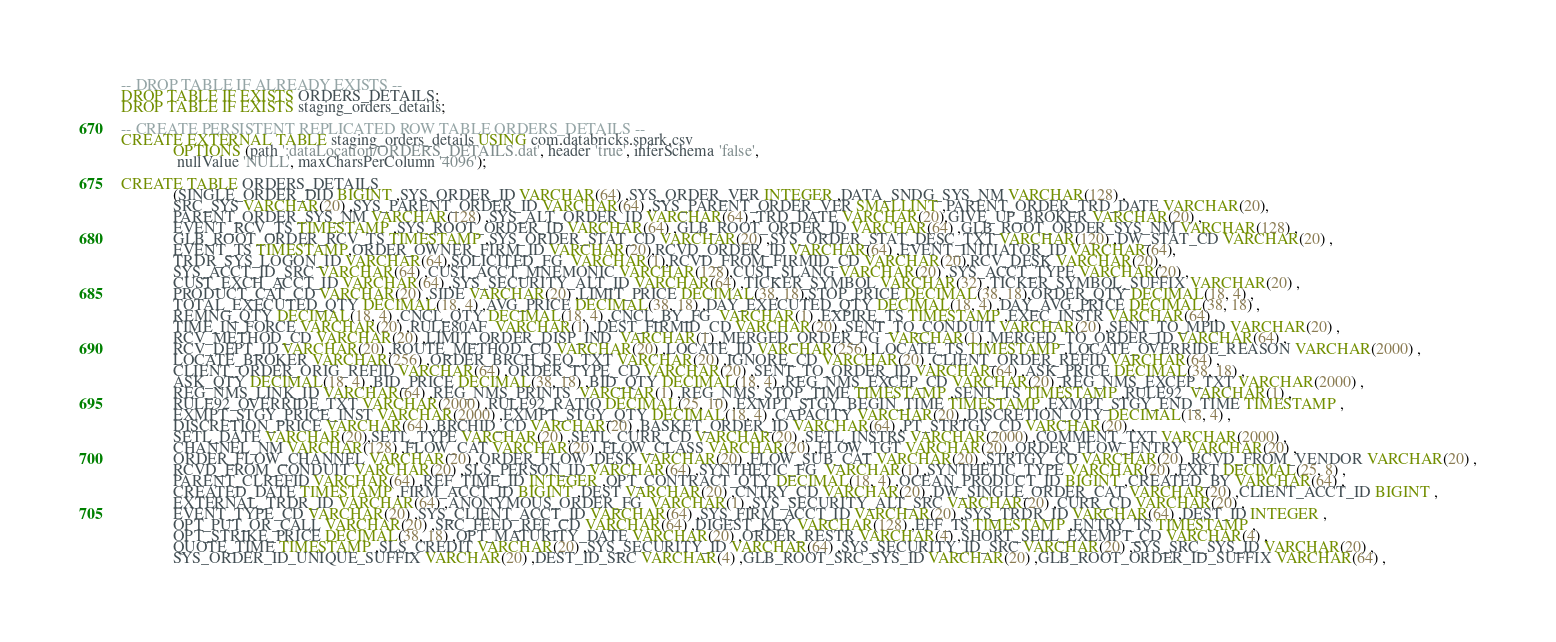Convert code to text. <code><loc_0><loc_0><loc_500><loc_500><_SQL_>-- DROP TABLE IF ALREADY EXISTS --
DROP TABLE IF EXISTS ORDERS_DETAILS;
DROP TABLE IF EXISTS staging_orders_details;

-- CREATE PERSISTENT REPLICATED ROW TABLE ORDERS_DETAILS --
CREATE EXTERNAL TABLE staging_orders_details USING com.databricks.spark.csv
             OPTIONS (path ':dataLocation/ORDERS_DETAILS.dat', header 'true', inferSchema 'false',
              nullValue 'NULL', maxCharsPerColumn '4096');

CREATE TABLE ORDERS_DETAILS
             (SINGLE_ORDER_DID BIGINT ,SYS_ORDER_ID VARCHAR(64) ,SYS_ORDER_VER INTEGER ,DATA_SNDG_SYS_NM VARCHAR(128) ,
             SRC_SYS VARCHAR(20) ,SYS_PARENT_ORDER_ID VARCHAR(64) ,SYS_PARENT_ORDER_VER SMALLINT ,PARENT_ORDER_TRD_DATE VARCHAR(20),
             PARENT_ORDER_SYS_NM VARCHAR(128) ,SYS_ALT_ORDER_ID VARCHAR(64) ,TRD_DATE VARCHAR(20),GIVE_UP_BROKER VARCHAR(20) ,
             EVENT_RCV_TS TIMESTAMP ,SYS_ROOT_ORDER_ID VARCHAR(64) ,GLB_ROOT_ORDER_ID VARCHAR(64) ,GLB_ROOT_ORDER_SYS_NM VARCHAR(128) ,
             GLB_ROOT_ORDER_RCV_TS TIMESTAMP ,SYS_ORDER_STAT_CD VARCHAR(20) ,SYS_ORDER_STAT_DESC_TXT VARCHAR(120) ,DW_STAT_CD VARCHAR(20) ,
             EVENT_TS TIMESTAMP,ORDER_OWNER_FIRM_ID VARCHAR(20),RCVD_ORDER_ID VARCHAR(64) ,EVENT_INITIATOR_ID VARCHAR(64),
             TRDR_SYS_LOGON_ID VARCHAR(64),SOLICITED_FG  VARCHAR(1),RCVD_FROM_FIRMID_CD VARCHAR(20),RCV_DESK VARCHAR(20),
             SYS_ACCT_ID_SRC VARCHAR(64) ,CUST_ACCT_MNEMONIC VARCHAR(128),CUST_SLANG VARCHAR(20) ,SYS_ACCT_TYPE VARCHAR(20) ,
             CUST_EXCH_ACCT_ID VARCHAR(64) ,SYS_SECURITY_ALT_ID VARCHAR(64) ,TICKER_SYMBOL VARCHAR(32) ,TICKER_SYMBOL_SUFFIX VARCHAR(20) ,
             PRODUCT_CAT_CD VARCHAR(20) ,SIDE VARCHAR(20) ,LIMIT_PRICE DECIMAL(38, 18),STOP_PRICE DECIMAL(38, 18),ORDER_QTY DECIMAL(18, 4) ,
             TOTAL_EXECUTED_QTY DECIMAL(18, 4) ,AVG_PRICE DECIMAL(38, 18) ,DAY_EXECUTED_QTY DECIMAL(18, 4) ,DAY_AVG_PRICE DECIMAL(38, 18) ,
             REMNG_QTY DECIMAL(18, 4) ,CNCL_QTY DECIMAL(18, 4) ,CNCL_BY_FG  VARCHAR(1) ,EXPIRE_TS TIMESTAMP ,EXEC_INSTR VARCHAR(64) ,
             TIME_IN_FORCE VARCHAR(20) ,RULE80AF  VARCHAR(1) ,DEST_FIRMID_CD VARCHAR(20) ,SENT_TO_CONDUIT VARCHAR(20) ,SENT_TO_MPID VARCHAR(20) ,
             RCV_METHOD_CD VARCHAR(20) ,LIMIT_ORDER_DISP_IND  VARCHAR(1) ,MERGED_ORDER_FG  VARCHAR(1) ,MERGED_TO_ORDER_ID VARCHAR(64) ,
             RCV_DEPT_ID VARCHAR(20) ,ROUTE_METHOD_CD VARCHAR(20) ,LOCATE_ID VARCHAR(256) ,LOCATE_TS TIMESTAMP ,LOCATE_OVERRIDE_REASON VARCHAR(2000) ,
             LOCATE_BROKER VARCHAR(256) ,ORDER_BRCH_SEQ_TXT VARCHAR(20) ,IGNORE_CD VARCHAR(20) ,CLIENT_ORDER_REFID VARCHAR(64) ,
             CLIENT_ORDER_ORIG_REFID VARCHAR(64) ,ORDER_TYPE_CD VARCHAR(20) ,SENT_TO_ORDER_ID VARCHAR(64) ,ASK_PRICE DECIMAL(38, 18) ,
             ASK_QTY DECIMAL(18, 4) ,BID_PRICE DECIMAL(38, 18) ,BID_QTY DECIMAL(18, 4) ,REG_NMS_EXCEP_CD VARCHAR(20) ,REG_NMS_EXCEP_TXT VARCHAR(2000) ,
             REG_NMS_LINK_ID VARCHAR(64) ,REG_NMS_PRINTS  VARCHAR(1) ,REG_NMS_STOP_TIME TIMESTAMP ,SENT_TS TIMESTAMP ,RULE92  VARCHAR(1) ,
             RULE92_OVERRIDE_TXT VARCHAR(2000) ,RULE92_RATIO DECIMAL(25, 10) ,EXMPT_STGY_BEGIN_TIME TIMESTAMP ,EXMPT_STGY_END_TIME TIMESTAMP ,
             EXMPT_STGY_PRICE_INST VARCHAR(2000) ,EXMPT_STGY_QTY DECIMAL(18, 4) ,CAPACITY VARCHAR(20) ,DISCRETION_QTY DECIMAL(18, 4) ,
             DISCRETION_PRICE VARCHAR(64) ,BRCHID_CD VARCHAR(20) ,BASKET_ORDER_ID VARCHAR(64) ,PT_STRTGY_CD VARCHAR(20) ,
             SETL_DATE VARCHAR(20),SETL_TYPE VARCHAR(20) ,SETL_CURR_CD VARCHAR(20) ,SETL_INSTRS VARCHAR(2000) ,COMMENT_TXT VARCHAR(2000) ,
             CHANNEL_NM VARCHAR(128) ,FLOW_CAT VARCHAR(20) ,FLOW_CLASS VARCHAR(20) ,FLOW_TGT VARCHAR(20) ,ORDER_FLOW_ENTRY VARCHAR(20) ,
             ORDER_FLOW_CHANNEL VARCHAR(20) ,ORDER_FLOW_DESK VARCHAR(20) ,FLOW_SUB_CAT VARCHAR(20) ,STRTGY_CD VARCHAR(20) ,RCVD_FROM_VENDOR VARCHAR(20) ,
             RCVD_FROM_CONDUIT VARCHAR(20) ,SLS_PERSON_ID VARCHAR(64) ,SYNTHETIC_FG  VARCHAR(1) ,SYNTHETIC_TYPE VARCHAR(20) ,FXRT DECIMAL(25, 8) ,
             PARENT_CLREFID VARCHAR(64) ,REF_TIME_ID INTEGER ,OPT_CONTRACT_QTY DECIMAL(18, 4) ,OCEAN_PRODUCT_ID BIGINT ,CREATED_BY VARCHAR(64) ,
             CREATED_DATE TIMESTAMP ,FIRM_ACCT_ID BIGINT ,DEST VARCHAR(20) ,CNTRY_CD VARCHAR(20) ,DW_SINGLE_ORDER_CAT VARCHAR(20) ,CLIENT_ACCT_ID BIGINT ,
             EXTERNAL_TRDR_ID VARCHAR(64) ,ANONYMOUS_ORDER_FG  VARCHAR(1) ,SYS_SECURITY_ALT_SRC VARCHAR(20) ,CURR_CD VARCHAR(20) ,
             EVENT_TYPE_CD VARCHAR(20) ,SYS_CLIENT_ACCT_ID VARCHAR(64) ,SYS_FIRM_ACCT_ID VARCHAR(20) ,SYS_TRDR_ID VARCHAR(64) ,DEST_ID INTEGER ,
             OPT_PUT_OR_CALL VARCHAR(20) ,SRC_FEED_REF_CD VARCHAR(64) ,DIGEST_KEY VARCHAR(128) ,EFF_TS TIMESTAMP ,ENTRY_TS TIMESTAMP ,
             OPT_STRIKE_PRICE DECIMAL(38, 18) ,OPT_MATURITY_DATE VARCHAR(20) ,ORDER_RESTR VARCHAR(4) ,SHORT_SELL_EXEMPT_CD VARCHAR(4) ,
             QUOTE_TIME TIMESTAMP ,SLS_CREDIT VARCHAR(20) ,SYS_SECURITY_ID VARCHAR(64) ,SYS_SECURITY_ID_SRC VARCHAR(20) ,SYS_SRC_SYS_ID VARCHAR(20) ,
             SYS_ORDER_ID_UNIQUE_SUFFIX VARCHAR(20) ,DEST_ID_SRC VARCHAR(4) ,GLB_ROOT_SRC_SYS_ID VARCHAR(20) ,GLB_ROOT_ORDER_ID_SUFFIX VARCHAR(64) ,</code> 